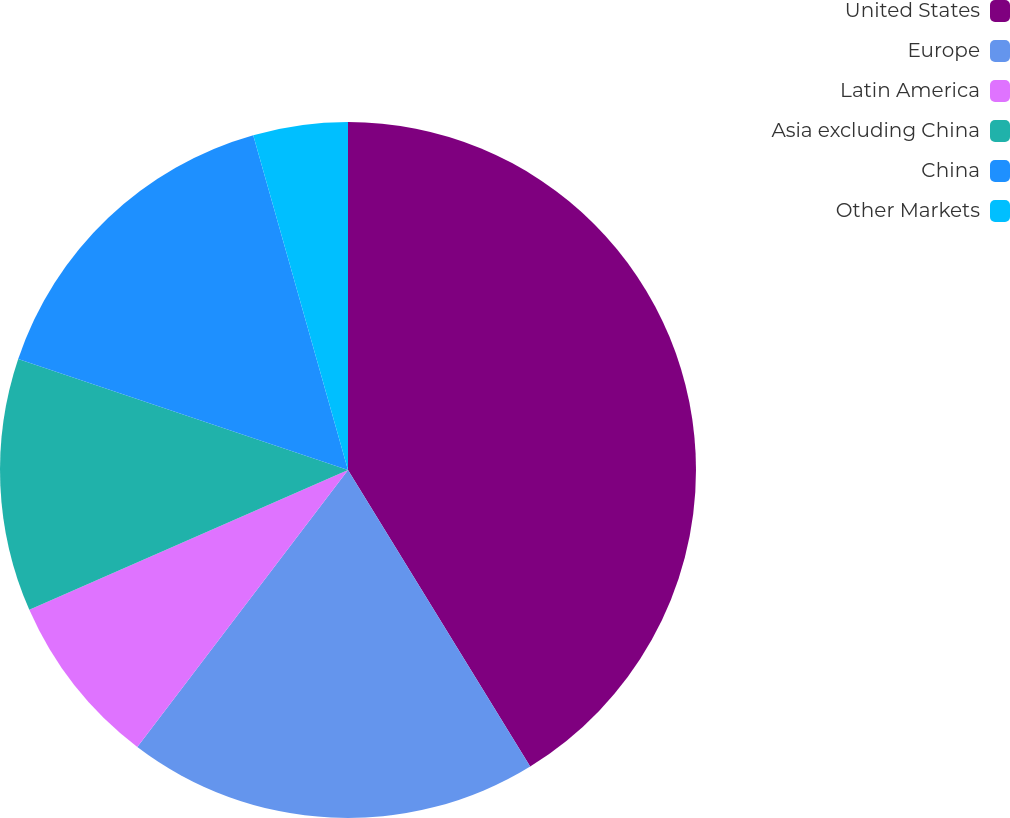<chart> <loc_0><loc_0><loc_500><loc_500><pie_chart><fcel>United States<fcel>Europe<fcel>Latin America<fcel>Asia excluding China<fcel>China<fcel>Other Markets<nl><fcel>41.23%<fcel>19.12%<fcel>8.07%<fcel>11.75%<fcel>15.44%<fcel>4.39%<nl></chart> 